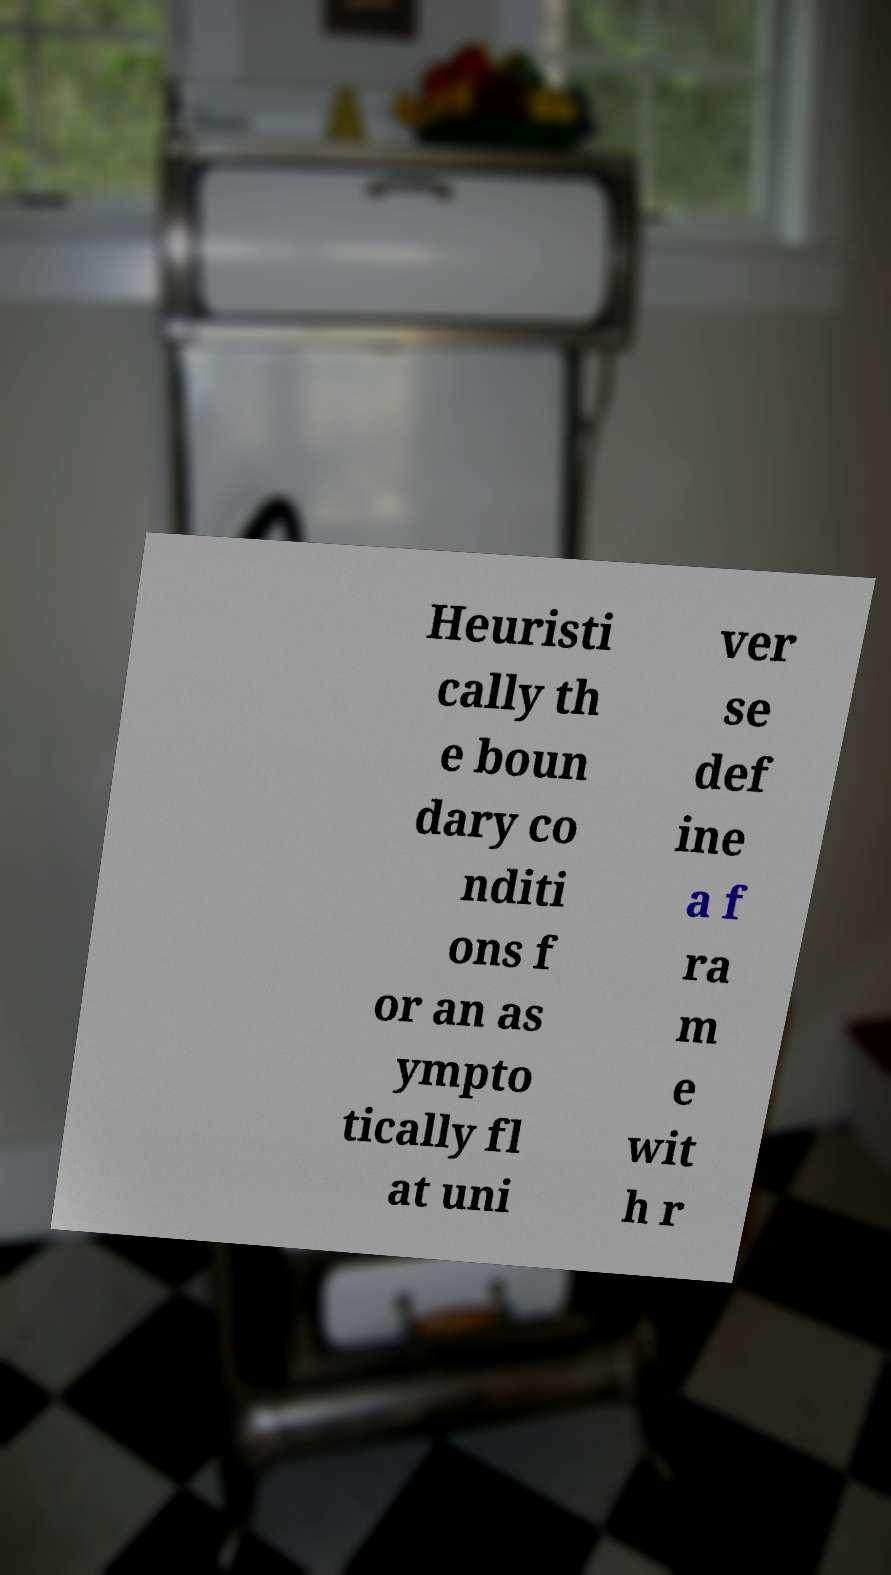Please read and relay the text visible in this image. What does it say? Heuristi cally th e boun dary co nditi ons f or an as ympto tically fl at uni ver se def ine a f ra m e wit h r 